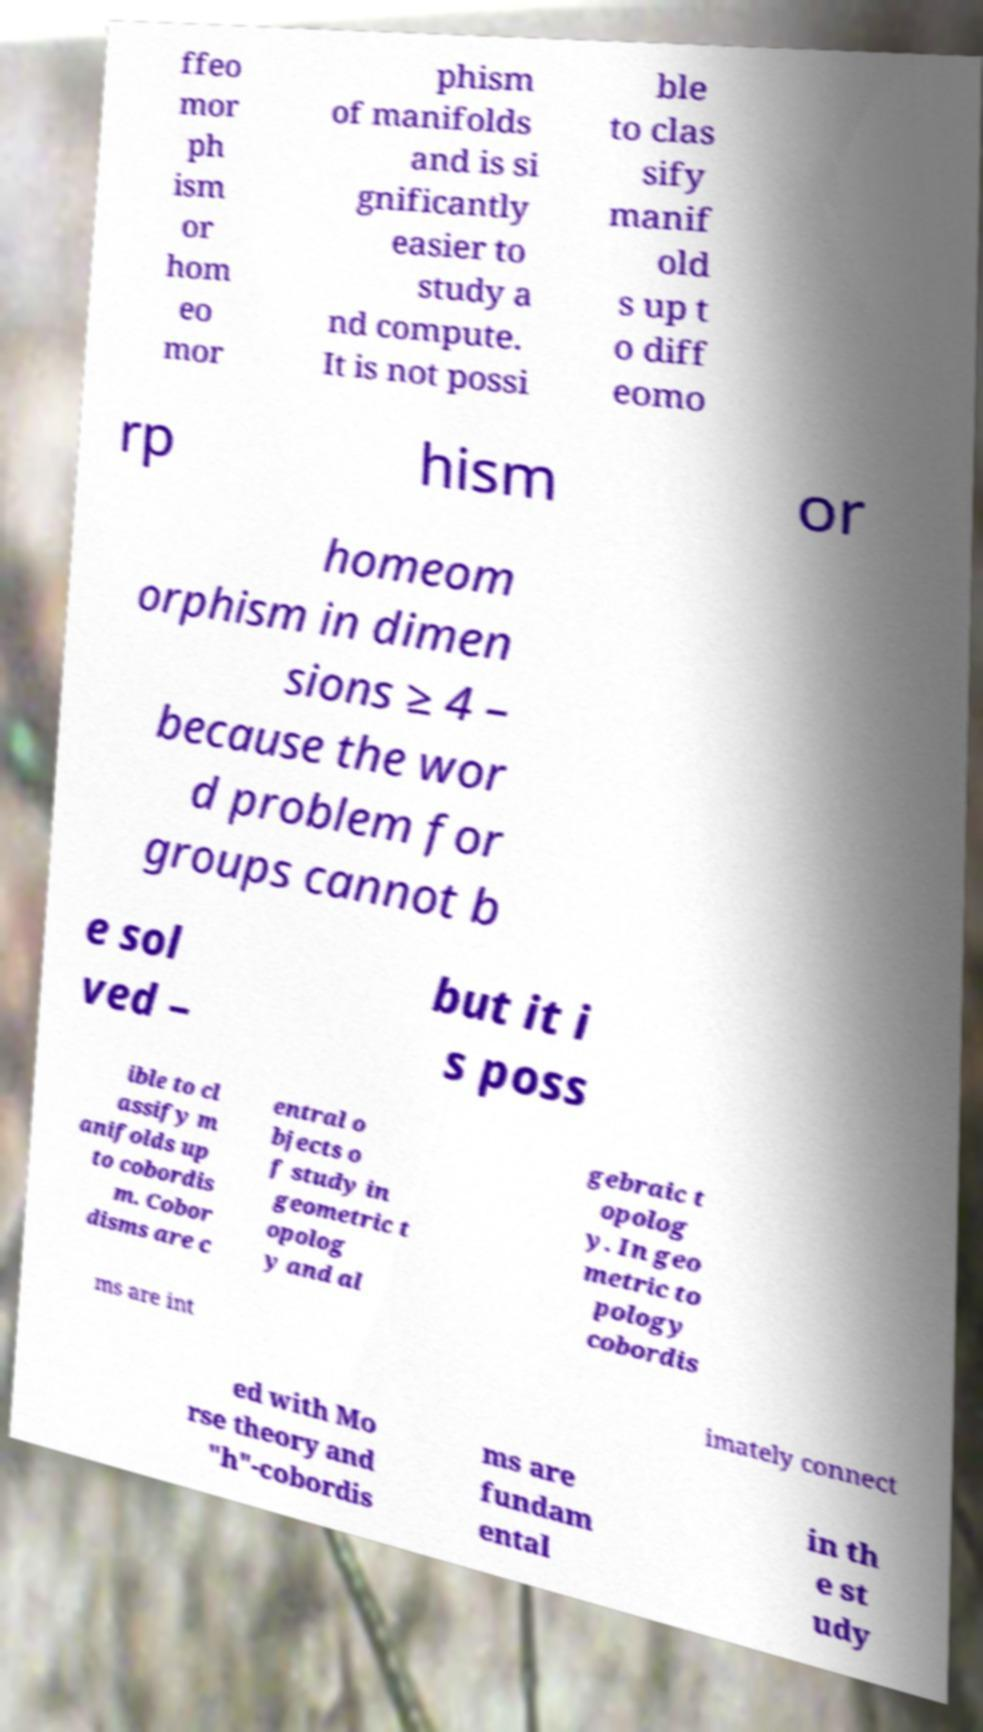Could you assist in decoding the text presented in this image and type it out clearly? ffeo mor ph ism or hom eo mor phism of manifolds and is si gnificantly easier to study a nd compute. It is not possi ble to clas sify manif old s up t o diff eomo rp hism or homeom orphism in dimen sions ≥ 4 – because the wor d problem for groups cannot b e sol ved – but it i s poss ible to cl assify m anifolds up to cobordis m. Cobor disms are c entral o bjects o f study in geometric t opolog y and al gebraic t opolog y. In geo metric to pology cobordis ms are int imately connect ed with Mo rse theory and "h"-cobordis ms are fundam ental in th e st udy 